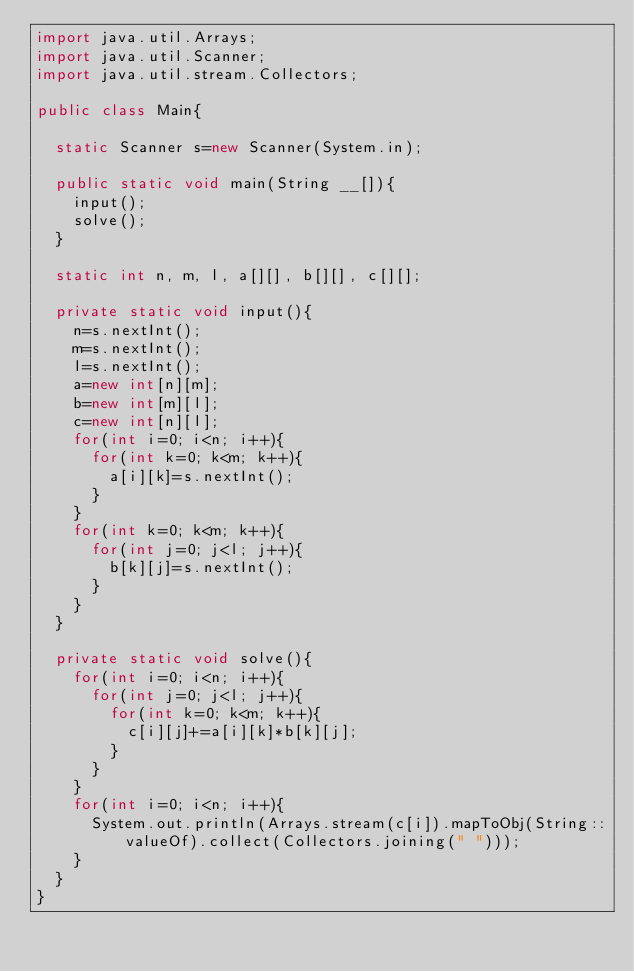Convert code to text. <code><loc_0><loc_0><loc_500><loc_500><_Java_>import java.util.Arrays;
import java.util.Scanner;
import java.util.stream.Collectors;

public class Main{

	static Scanner s=new Scanner(System.in);

	public static void main(String __[]){
		input();
		solve();
	}

	static int n, m, l, a[][], b[][], c[][];

	private static void input(){
		n=s.nextInt();
		m=s.nextInt();
		l=s.nextInt();
		a=new int[n][m];
		b=new int[m][l];
		c=new int[n][l];
		for(int i=0; i<n; i++){
			for(int k=0; k<m; k++){
				a[i][k]=s.nextInt();
			}
		}
		for(int k=0; k<m; k++){
			for(int j=0; j<l; j++){
				b[k][j]=s.nextInt();
			}
		}
	}

	private static void solve(){
		for(int i=0; i<n; i++){
			for(int j=0; j<l; j++){
				for(int k=0; k<m; k++){
					c[i][j]+=a[i][k]*b[k][j];
				}
			}
		}
		for(int i=0; i<n; i++){
			System.out.println(Arrays.stream(c[i]).mapToObj(String::valueOf).collect(Collectors.joining(" ")));
		}
	}
}</code> 